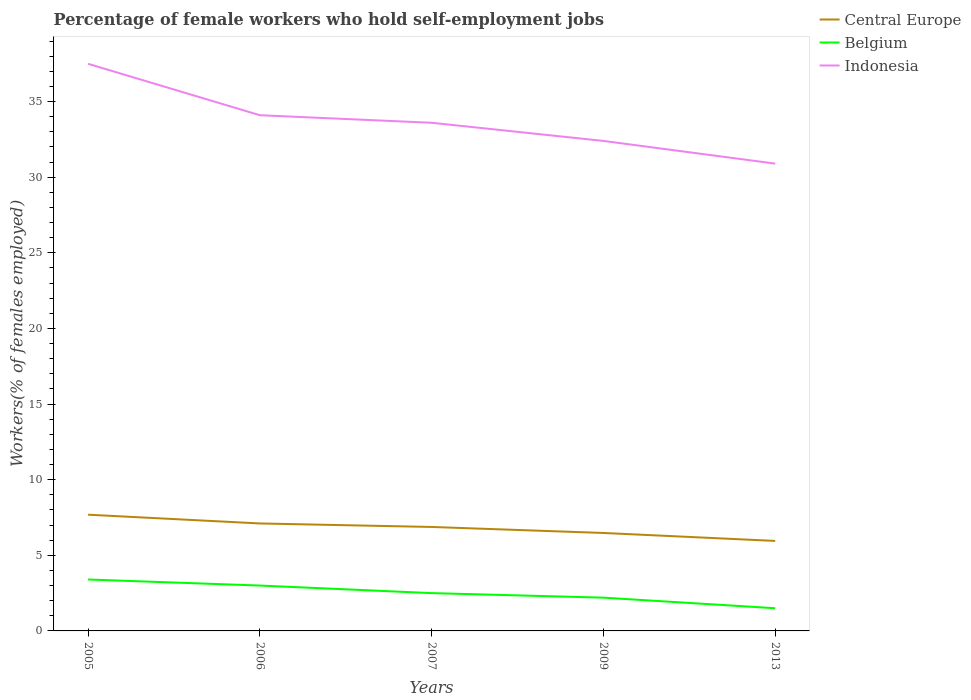How many different coloured lines are there?
Your answer should be compact. 3. Across all years, what is the maximum percentage of self-employed female workers in Indonesia?
Your answer should be compact. 30.9. In which year was the percentage of self-employed female workers in Central Europe maximum?
Ensure brevity in your answer.  2013. What is the total percentage of self-employed female workers in Indonesia in the graph?
Offer a terse response. 5.1. What is the difference between the highest and the second highest percentage of self-employed female workers in Indonesia?
Offer a terse response. 6.6. What is the difference between the highest and the lowest percentage of self-employed female workers in Belgium?
Provide a short and direct response. 2. How many lines are there?
Provide a short and direct response. 3. What is the difference between two consecutive major ticks on the Y-axis?
Offer a very short reply. 5. Are the values on the major ticks of Y-axis written in scientific E-notation?
Your answer should be very brief. No. Does the graph contain any zero values?
Provide a succinct answer. No. Does the graph contain grids?
Provide a short and direct response. No. Where does the legend appear in the graph?
Provide a succinct answer. Top right. How are the legend labels stacked?
Ensure brevity in your answer.  Vertical. What is the title of the graph?
Offer a terse response. Percentage of female workers who hold self-employment jobs. What is the label or title of the X-axis?
Give a very brief answer. Years. What is the label or title of the Y-axis?
Your answer should be compact. Workers(% of females employed). What is the Workers(% of females employed) in Central Europe in 2005?
Provide a succinct answer. 7.69. What is the Workers(% of females employed) of Belgium in 2005?
Give a very brief answer. 3.4. What is the Workers(% of females employed) in Indonesia in 2005?
Keep it short and to the point. 37.5. What is the Workers(% of females employed) in Central Europe in 2006?
Ensure brevity in your answer.  7.11. What is the Workers(% of females employed) in Belgium in 2006?
Make the answer very short. 3. What is the Workers(% of females employed) in Indonesia in 2006?
Keep it short and to the point. 34.1. What is the Workers(% of females employed) of Central Europe in 2007?
Provide a short and direct response. 6.87. What is the Workers(% of females employed) in Indonesia in 2007?
Keep it short and to the point. 33.6. What is the Workers(% of females employed) of Central Europe in 2009?
Give a very brief answer. 6.48. What is the Workers(% of females employed) in Belgium in 2009?
Provide a succinct answer. 2.2. What is the Workers(% of females employed) in Indonesia in 2009?
Give a very brief answer. 32.4. What is the Workers(% of females employed) in Central Europe in 2013?
Give a very brief answer. 5.95. What is the Workers(% of females employed) of Indonesia in 2013?
Provide a succinct answer. 30.9. Across all years, what is the maximum Workers(% of females employed) of Central Europe?
Ensure brevity in your answer.  7.69. Across all years, what is the maximum Workers(% of females employed) of Belgium?
Give a very brief answer. 3.4. Across all years, what is the maximum Workers(% of females employed) of Indonesia?
Make the answer very short. 37.5. Across all years, what is the minimum Workers(% of females employed) in Central Europe?
Provide a succinct answer. 5.95. Across all years, what is the minimum Workers(% of females employed) in Belgium?
Keep it short and to the point. 1.5. Across all years, what is the minimum Workers(% of females employed) in Indonesia?
Your answer should be very brief. 30.9. What is the total Workers(% of females employed) in Central Europe in the graph?
Offer a very short reply. 34.09. What is the total Workers(% of females employed) in Belgium in the graph?
Keep it short and to the point. 12.6. What is the total Workers(% of females employed) in Indonesia in the graph?
Keep it short and to the point. 168.5. What is the difference between the Workers(% of females employed) in Central Europe in 2005 and that in 2006?
Your response must be concise. 0.58. What is the difference between the Workers(% of females employed) of Central Europe in 2005 and that in 2007?
Keep it short and to the point. 0.81. What is the difference between the Workers(% of females employed) in Belgium in 2005 and that in 2007?
Keep it short and to the point. 0.9. What is the difference between the Workers(% of females employed) in Central Europe in 2005 and that in 2009?
Provide a succinct answer. 1.21. What is the difference between the Workers(% of females employed) of Indonesia in 2005 and that in 2009?
Give a very brief answer. 5.1. What is the difference between the Workers(% of females employed) of Central Europe in 2005 and that in 2013?
Your response must be concise. 1.73. What is the difference between the Workers(% of females employed) in Belgium in 2005 and that in 2013?
Ensure brevity in your answer.  1.9. What is the difference between the Workers(% of females employed) in Central Europe in 2006 and that in 2007?
Make the answer very short. 0.23. What is the difference between the Workers(% of females employed) of Belgium in 2006 and that in 2007?
Make the answer very short. 0.5. What is the difference between the Workers(% of females employed) of Indonesia in 2006 and that in 2007?
Provide a succinct answer. 0.5. What is the difference between the Workers(% of females employed) of Central Europe in 2006 and that in 2009?
Ensure brevity in your answer.  0.63. What is the difference between the Workers(% of females employed) of Belgium in 2006 and that in 2009?
Provide a short and direct response. 0.8. What is the difference between the Workers(% of females employed) of Central Europe in 2006 and that in 2013?
Provide a short and direct response. 1.16. What is the difference between the Workers(% of females employed) of Belgium in 2006 and that in 2013?
Give a very brief answer. 1.5. What is the difference between the Workers(% of females employed) of Indonesia in 2006 and that in 2013?
Offer a terse response. 3.2. What is the difference between the Workers(% of females employed) in Central Europe in 2007 and that in 2009?
Give a very brief answer. 0.4. What is the difference between the Workers(% of females employed) of Indonesia in 2007 and that in 2009?
Make the answer very short. 1.2. What is the difference between the Workers(% of females employed) in Central Europe in 2007 and that in 2013?
Ensure brevity in your answer.  0.92. What is the difference between the Workers(% of females employed) in Indonesia in 2007 and that in 2013?
Make the answer very short. 2.7. What is the difference between the Workers(% of females employed) in Central Europe in 2009 and that in 2013?
Keep it short and to the point. 0.53. What is the difference between the Workers(% of females employed) of Belgium in 2009 and that in 2013?
Offer a very short reply. 0.7. What is the difference between the Workers(% of females employed) in Central Europe in 2005 and the Workers(% of females employed) in Belgium in 2006?
Provide a short and direct response. 4.69. What is the difference between the Workers(% of females employed) in Central Europe in 2005 and the Workers(% of females employed) in Indonesia in 2006?
Ensure brevity in your answer.  -26.41. What is the difference between the Workers(% of females employed) of Belgium in 2005 and the Workers(% of females employed) of Indonesia in 2006?
Offer a very short reply. -30.7. What is the difference between the Workers(% of females employed) in Central Europe in 2005 and the Workers(% of females employed) in Belgium in 2007?
Ensure brevity in your answer.  5.19. What is the difference between the Workers(% of females employed) in Central Europe in 2005 and the Workers(% of females employed) in Indonesia in 2007?
Your answer should be compact. -25.91. What is the difference between the Workers(% of females employed) in Belgium in 2005 and the Workers(% of females employed) in Indonesia in 2007?
Make the answer very short. -30.2. What is the difference between the Workers(% of females employed) in Central Europe in 2005 and the Workers(% of females employed) in Belgium in 2009?
Provide a short and direct response. 5.49. What is the difference between the Workers(% of females employed) of Central Europe in 2005 and the Workers(% of females employed) of Indonesia in 2009?
Your answer should be very brief. -24.71. What is the difference between the Workers(% of females employed) of Central Europe in 2005 and the Workers(% of females employed) of Belgium in 2013?
Your answer should be compact. 6.19. What is the difference between the Workers(% of females employed) in Central Europe in 2005 and the Workers(% of females employed) in Indonesia in 2013?
Provide a short and direct response. -23.21. What is the difference between the Workers(% of females employed) of Belgium in 2005 and the Workers(% of females employed) of Indonesia in 2013?
Give a very brief answer. -27.5. What is the difference between the Workers(% of females employed) of Central Europe in 2006 and the Workers(% of females employed) of Belgium in 2007?
Ensure brevity in your answer.  4.61. What is the difference between the Workers(% of females employed) in Central Europe in 2006 and the Workers(% of females employed) in Indonesia in 2007?
Offer a terse response. -26.49. What is the difference between the Workers(% of females employed) of Belgium in 2006 and the Workers(% of females employed) of Indonesia in 2007?
Keep it short and to the point. -30.6. What is the difference between the Workers(% of females employed) of Central Europe in 2006 and the Workers(% of females employed) of Belgium in 2009?
Provide a succinct answer. 4.91. What is the difference between the Workers(% of females employed) of Central Europe in 2006 and the Workers(% of females employed) of Indonesia in 2009?
Offer a terse response. -25.29. What is the difference between the Workers(% of females employed) in Belgium in 2006 and the Workers(% of females employed) in Indonesia in 2009?
Your answer should be compact. -29.4. What is the difference between the Workers(% of females employed) in Central Europe in 2006 and the Workers(% of females employed) in Belgium in 2013?
Make the answer very short. 5.61. What is the difference between the Workers(% of females employed) in Central Europe in 2006 and the Workers(% of females employed) in Indonesia in 2013?
Your response must be concise. -23.79. What is the difference between the Workers(% of females employed) of Belgium in 2006 and the Workers(% of females employed) of Indonesia in 2013?
Offer a terse response. -27.9. What is the difference between the Workers(% of females employed) in Central Europe in 2007 and the Workers(% of females employed) in Belgium in 2009?
Give a very brief answer. 4.67. What is the difference between the Workers(% of females employed) of Central Europe in 2007 and the Workers(% of females employed) of Indonesia in 2009?
Offer a very short reply. -25.53. What is the difference between the Workers(% of females employed) of Belgium in 2007 and the Workers(% of females employed) of Indonesia in 2009?
Make the answer very short. -29.9. What is the difference between the Workers(% of females employed) in Central Europe in 2007 and the Workers(% of females employed) in Belgium in 2013?
Offer a very short reply. 5.37. What is the difference between the Workers(% of females employed) in Central Europe in 2007 and the Workers(% of females employed) in Indonesia in 2013?
Ensure brevity in your answer.  -24.03. What is the difference between the Workers(% of females employed) in Belgium in 2007 and the Workers(% of females employed) in Indonesia in 2013?
Offer a terse response. -28.4. What is the difference between the Workers(% of females employed) in Central Europe in 2009 and the Workers(% of females employed) in Belgium in 2013?
Your response must be concise. 4.98. What is the difference between the Workers(% of females employed) of Central Europe in 2009 and the Workers(% of females employed) of Indonesia in 2013?
Give a very brief answer. -24.42. What is the difference between the Workers(% of females employed) of Belgium in 2009 and the Workers(% of females employed) of Indonesia in 2013?
Offer a terse response. -28.7. What is the average Workers(% of females employed) in Central Europe per year?
Make the answer very short. 6.82. What is the average Workers(% of females employed) in Belgium per year?
Ensure brevity in your answer.  2.52. What is the average Workers(% of females employed) in Indonesia per year?
Make the answer very short. 33.7. In the year 2005, what is the difference between the Workers(% of females employed) in Central Europe and Workers(% of females employed) in Belgium?
Provide a succinct answer. 4.29. In the year 2005, what is the difference between the Workers(% of females employed) of Central Europe and Workers(% of females employed) of Indonesia?
Give a very brief answer. -29.81. In the year 2005, what is the difference between the Workers(% of females employed) in Belgium and Workers(% of females employed) in Indonesia?
Provide a succinct answer. -34.1. In the year 2006, what is the difference between the Workers(% of females employed) in Central Europe and Workers(% of females employed) in Belgium?
Your answer should be very brief. 4.11. In the year 2006, what is the difference between the Workers(% of females employed) of Central Europe and Workers(% of females employed) of Indonesia?
Ensure brevity in your answer.  -26.99. In the year 2006, what is the difference between the Workers(% of females employed) in Belgium and Workers(% of females employed) in Indonesia?
Keep it short and to the point. -31.1. In the year 2007, what is the difference between the Workers(% of females employed) in Central Europe and Workers(% of females employed) in Belgium?
Provide a succinct answer. 4.37. In the year 2007, what is the difference between the Workers(% of females employed) in Central Europe and Workers(% of females employed) in Indonesia?
Keep it short and to the point. -26.73. In the year 2007, what is the difference between the Workers(% of females employed) of Belgium and Workers(% of females employed) of Indonesia?
Offer a terse response. -31.1. In the year 2009, what is the difference between the Workers(% of females employed) in Central Europe and Workers(% of females employed) in Belgium?
Make the answer very short. 4.28. In the year 2009, what is the difference between the Workers(% of females employed) in Central Europe and Workers(% of females employed) in Indonesia?
Provide a succinct answer. -25.92. In the year 2009, what is the difference between the Workers(% of females employed) of Belgium and Workers(% of females employed) of Indonesia?
Your response must be concise. -30.2. In the year 2013, what is the difference between the Workers(% of females employed) of Central Europe and Workers(% of females employed) of Belgium?
Provide a succinct answer. 4.45. In the year 2013, what is the difference between the Workers(% of females employed) in Central Europe and Workers(% of females employed) in Indonesia?
Offer a terse response. -24.95. In the year 2013, what is the difference between the Workers(% of females employed) of Belgium and Workers(% of females employed) of Indonesia?
Your answer should be very brief. -29.4. What is the ratio of the Workers(% of females employed) of Central Europe in 2005 to that in 2006?
Offer a very short reply. 1.08. What is the ratio of the Workers(% of females employed) in Belgium in 2005 to that in 2006?
Make the answer very short. 1.13. What is the ratio of the Workers(% of females employed) of Indonesia in 2005 to that in 2006?
Your answer should be compact. 1.1. What is the ratio of the Workers(% of females employed) in Central Europe in 2005 to that in 2007?
Your answer should be very brief. 1.12. What is the ratio of the Workers(% of females employed) in Belgium in 2005 to that in 2007?
Make the answer very short. 1.36. What is the ratio of the Workers(% of females employed) in Indonesia in 2005 to that in 2007?
Offer a terse response. 1.12. What is the ratio of the Workers(% of females employed) in Central Europe in 2005 to that in 2009?
Provide a short and direct response. 1.19. What is the ratio of the Workers(% of females employed) of Belgium in 2005 to that in 2009?
Make the answer very short. 1.55. What is the ratio of the Workers(% of females employed) of Indonesia in 2005 to that in 2009?
Your answer should be compact. 1.16. What is the ratio of the Workers(% of females employed) of Central Europe in 2005 to that in 2013?
Make the answer very short. 1.29. What is the ratio of the Workers(% of females employed) in Belgium in 2005 to that in 2013?
Your answer should be very brief. 2.27. What is the ratio of the Workers(% of females employed) of Indonesia in 2005 to that in 2013?
Ensure brevity in your answer.  1.21. What is the ratio of the Workers(% of females employed) in Central Europe in 2006 to that in 2007?
Your response must be concise. 1.03. What is the ratio of the Workers(% of females employed) of Belgium in 2006 to that in 2007?
Give a very brief answer. 1.2. What is the ratio of the Workers(% of females employed) of Indonesia in 2006 to that in 2007?
Make the answer very short. 1.01. What is the ratio of the Workers(% of females employed) in Central Europe in 2006 to that in 2009?
Make the answer very short. 1.1. What is the ratio of the Workers(% of females employed) of Belgium in 2006 to that in 2009?
Provide a short and direct response. 1.36. What is the ratio of the Workers(% of females employed) of Indonesia in 2006 to that in 2009?
Your response must be concise. 1.05. What is the ratio of the Workers(% of females employed) of Central Europe in 2006 to that in 2013?
Offer a terse response. 1.19. What is the ratio of the Workers(% of females employed) in Belgium in 2006 to that in 2013?
Offer a very short reply. 2. What is the ratio of the Workers(% of females employed) of Indonesia in 2006 to that in 2013?
Your response must be concise. 1.1. What is the ratio of the Workers(% of females employed) in Central Europe in 2007 to that in 2009?
Make the answer very short. 1.06. What is the ratio of the Workers(% of females employed) of Belgium in 2007 to that in 2009?
Your answer should be very brief. 1.14. What is the ratio of the Workers(% of females employed) of Indonesia in 2007 to that in 2009?
Provide a short and direct response. 1.04. What is the ratio of the Workers(% of females employed) in Central Europe in 2007 to that in 2013?
Offer a very short reply. 1.16. What is the ratio of the Workers(% of females employed) in Belgium in 2007 to that in 2013?
Offer a very short reply. 1.67. What is the ratio of the Workers(% of females employed) in Indonesia in 2007 to that in 2013?
Keep it short and to the point. 1.09. What is the ratio of the Workers(% of females employed) of Central Europe in 2009 to that in 2013?
Your response must be concise. 1.09. What is the ratio of the Workers(% of females employed) in Belgium in 2009 to that in 2013?
Your response must be concise. 1.47. What is the ratio of the Workers(% of females employed) in Indonesia in 2009 to that in 2013?
Ensure brevity in your answer.  1.05. What is the difference between the highest and the second highest Workers(% of females employed) of Central Europe?
Keep it short and to the point. 0.58. What is the difference between the highest and the lowest Workers(% of females employed) of Central Europe?
Give a very brief answer. 1.73. What is the difference between the highest and the lowest Workers(% of females employed) of Belgium?
Ensure brevity in your answer.  1.9. 